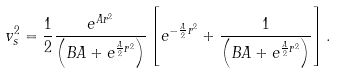Convert formula to latex. <formula><loc_0><loc_0><loc_500><loc_500>v _ { s } ^ { 2 } = \frac { 1 } { 2 } \frac { e ^ { A r ^ { 2 } } } { \left ( B A + e ^ { \frac { A } { 2 } r ^ { 2 } } \right ) } \left [ e ^ { - \frac { A } { 2 } r ^ { 2 } } + \frac { 1 } { \left ( B A + e ^ { \frac { A } { 2 } r ^ { 2 } } \right ) } \right ] .</formula> 